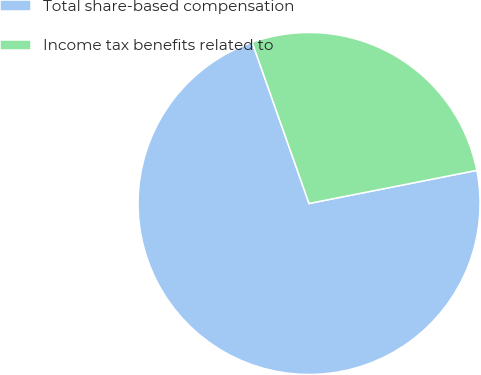Convert chart. <chart><loc_0><loc_0><loc_500><loc_500><pie_chart><fcel>Total share-based compensation<fcel>Income tax benefits related to<nl><fcel>72.7%<fcel>27.3%<nl></chart> 